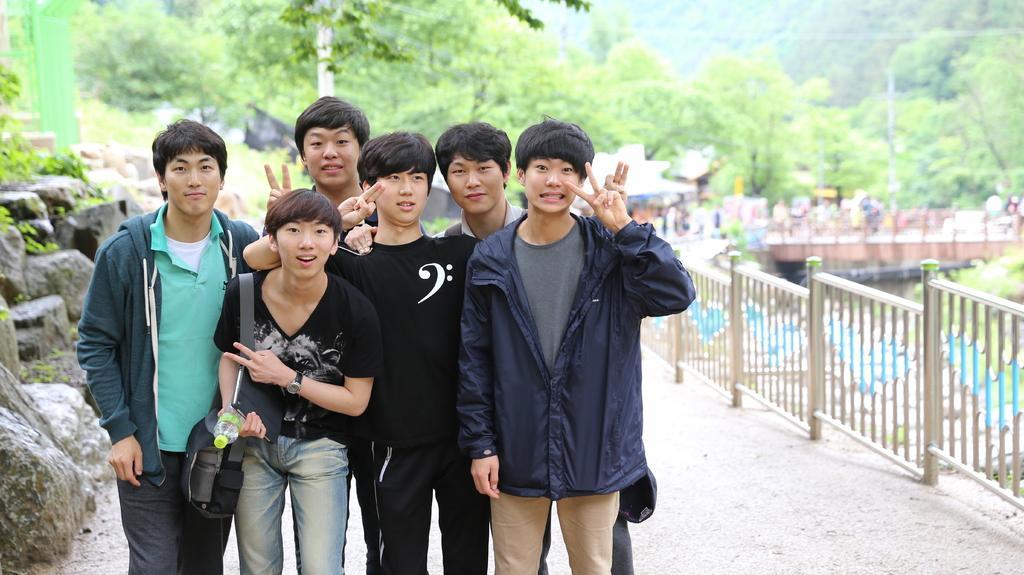In one or two sentences, can you explain what this image depicts? As we can see in the image there are group of people standing. There is fence, water, bridge, rocks and trees. In the background there is a building. 